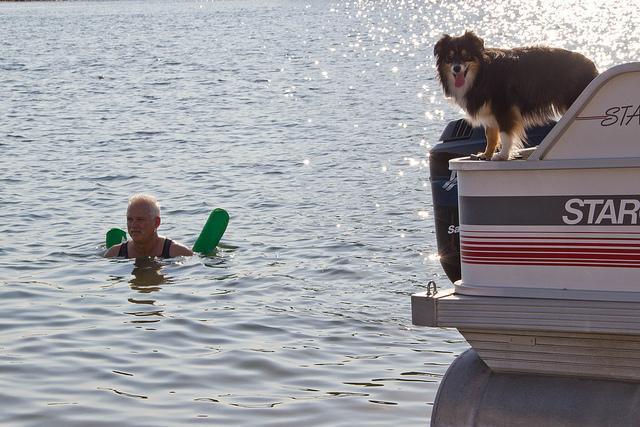How many boats are visible?
Give a very brief answer. 1. 